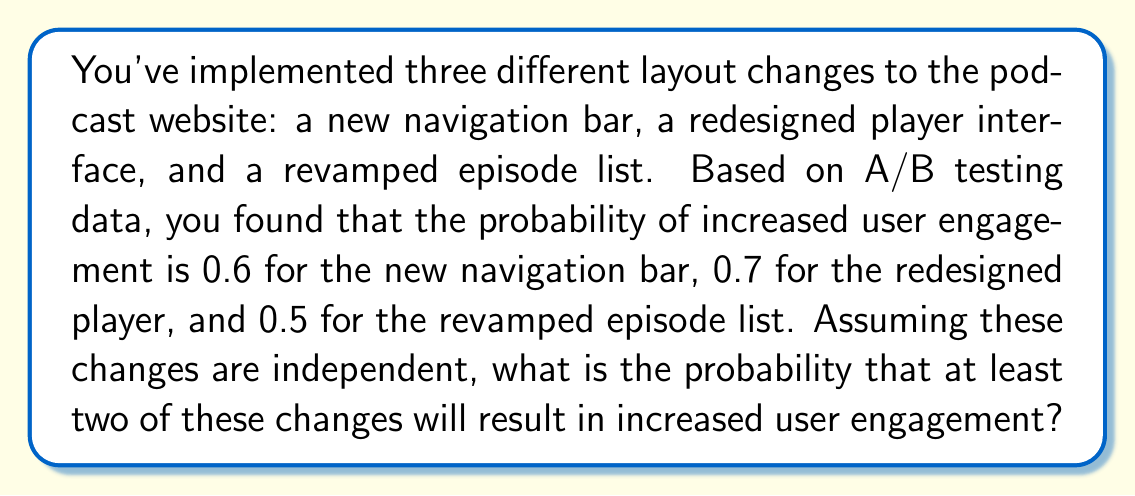Show me your answer to this math problem. Let's approach this step-by-step using the complement method:

1) First, let's define our events:
   A: New navigation bar increases engagement (P(A) = 0.6)
   B: Redesigned player increases engagement (P(B) = 0.7)
   C: Revamped episode list increases engagement (P(C) = 0.5)

2) We want to find P(at least two changes increase engagement). It's easier to calculate the complement: P(fewer than two changes increase engagement).

3) The complement includes two scenarios:
   - No changes increase engagement
   - Exactly one change increases engagement

4) Probability of no changes increasing engagement:
   P(none) = (1 - 0.6) * (1 - 0.7) * (1 - 0.5) = 0.4 * 0.3 * 0.5 = 0.06

5) Probability of exactly one change increasing engagement:
   P(only A) = 0.6 * 0.3 * 0.5 = 0.09
   P(only B) = 0.4 * 0.7 * 0.5 = 0.14
   P(only C) = 0.4 * 0.3 * 0.5 = 0.06
   P(exactly one) = 0.09 + 0.14 + 0.06 = 0.29

6) Probability of fewer than two changes increasing engagement:
   P(fewer than two) = P(none) + P(exactly one) = 0.06 + 0.29 = 0.35

7) Therefore, the probability of at least two changes increasing engagement is:
   P(at least two) = 1 - P(fewer than two) = 1 - 0.35 = 0.65

Thus, there's a 65% chance that at least two of the changes will result in increased user engagement.
Answer: 0.65 